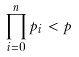<formula> <loc_0><loc_0><loc_500><loc_500>\prod _ { i = 0 } ^ { n } p _ { i } < p</formula> 